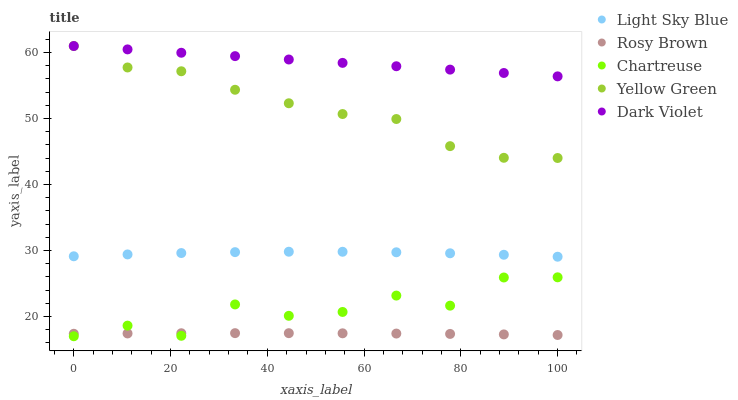Does Rosy Brown have the minimum area under the curve?
Answer yes or no. Yes. Does Dark Violet have the maximum area under the curve?
Answer yes or no. Yes. Does Light Sky Blue have the minimum area under the curve?
Answer yes or no. No. Does Light Sky Blue have the maximum area under the curve?
Answer yes or no. No. Is Dark Violet the smoothest?
Answer yes or no. Yes. Is Chartreuse the roughest?
Answer yes or no. Yes. Is Light Sky Blue the smoothest?
Answer yes or no. No. Is Light Sky Blue the roughest?
Answer yes or no. No. Does Chartreuse have the lowest value?
Answer yes or no. Yes. Does Light Sky Blue have the lowest value?
Answer yes or no. No. Does Yellow Green have the highest value?
Answer yes or no. Yes. Does Light Sky Blue have the highest value?
Answer yes or no. No. Is Chartreuse less than Yellow Green?
Answer yes or no. Yes. Is Dark Violet greater than Rosy Brown?
Answer yes or no. Yes. Does Chartreuse intersect Rosy Brown?
Answer yes or no. Yes. Is Chartreuse less than Rosy Brown?
Answer yes or no. No. Is Chartreuse greater than Rosy Brown?
Answer yes or no. No. Does Chartreuse intersect Yellow Green?
Answer yes or no. No. 